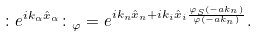Convert formula to latex. <formula><loc_0><loc_0><loc_500><loc_500>\colon e ^ { i k _ { \alpha } { \hat { x } } _ { \alpha } } \colon _ { \varphi } = e ^ { i k _ { n } { \hat { x } } _ { n } + i k _ { i } { \hat { x } } _ { i } \frac { { \varphi } _ { S } ( - a k _ { n } ) } { \varphi ( - a k _ { n } ) } } .</formula> 